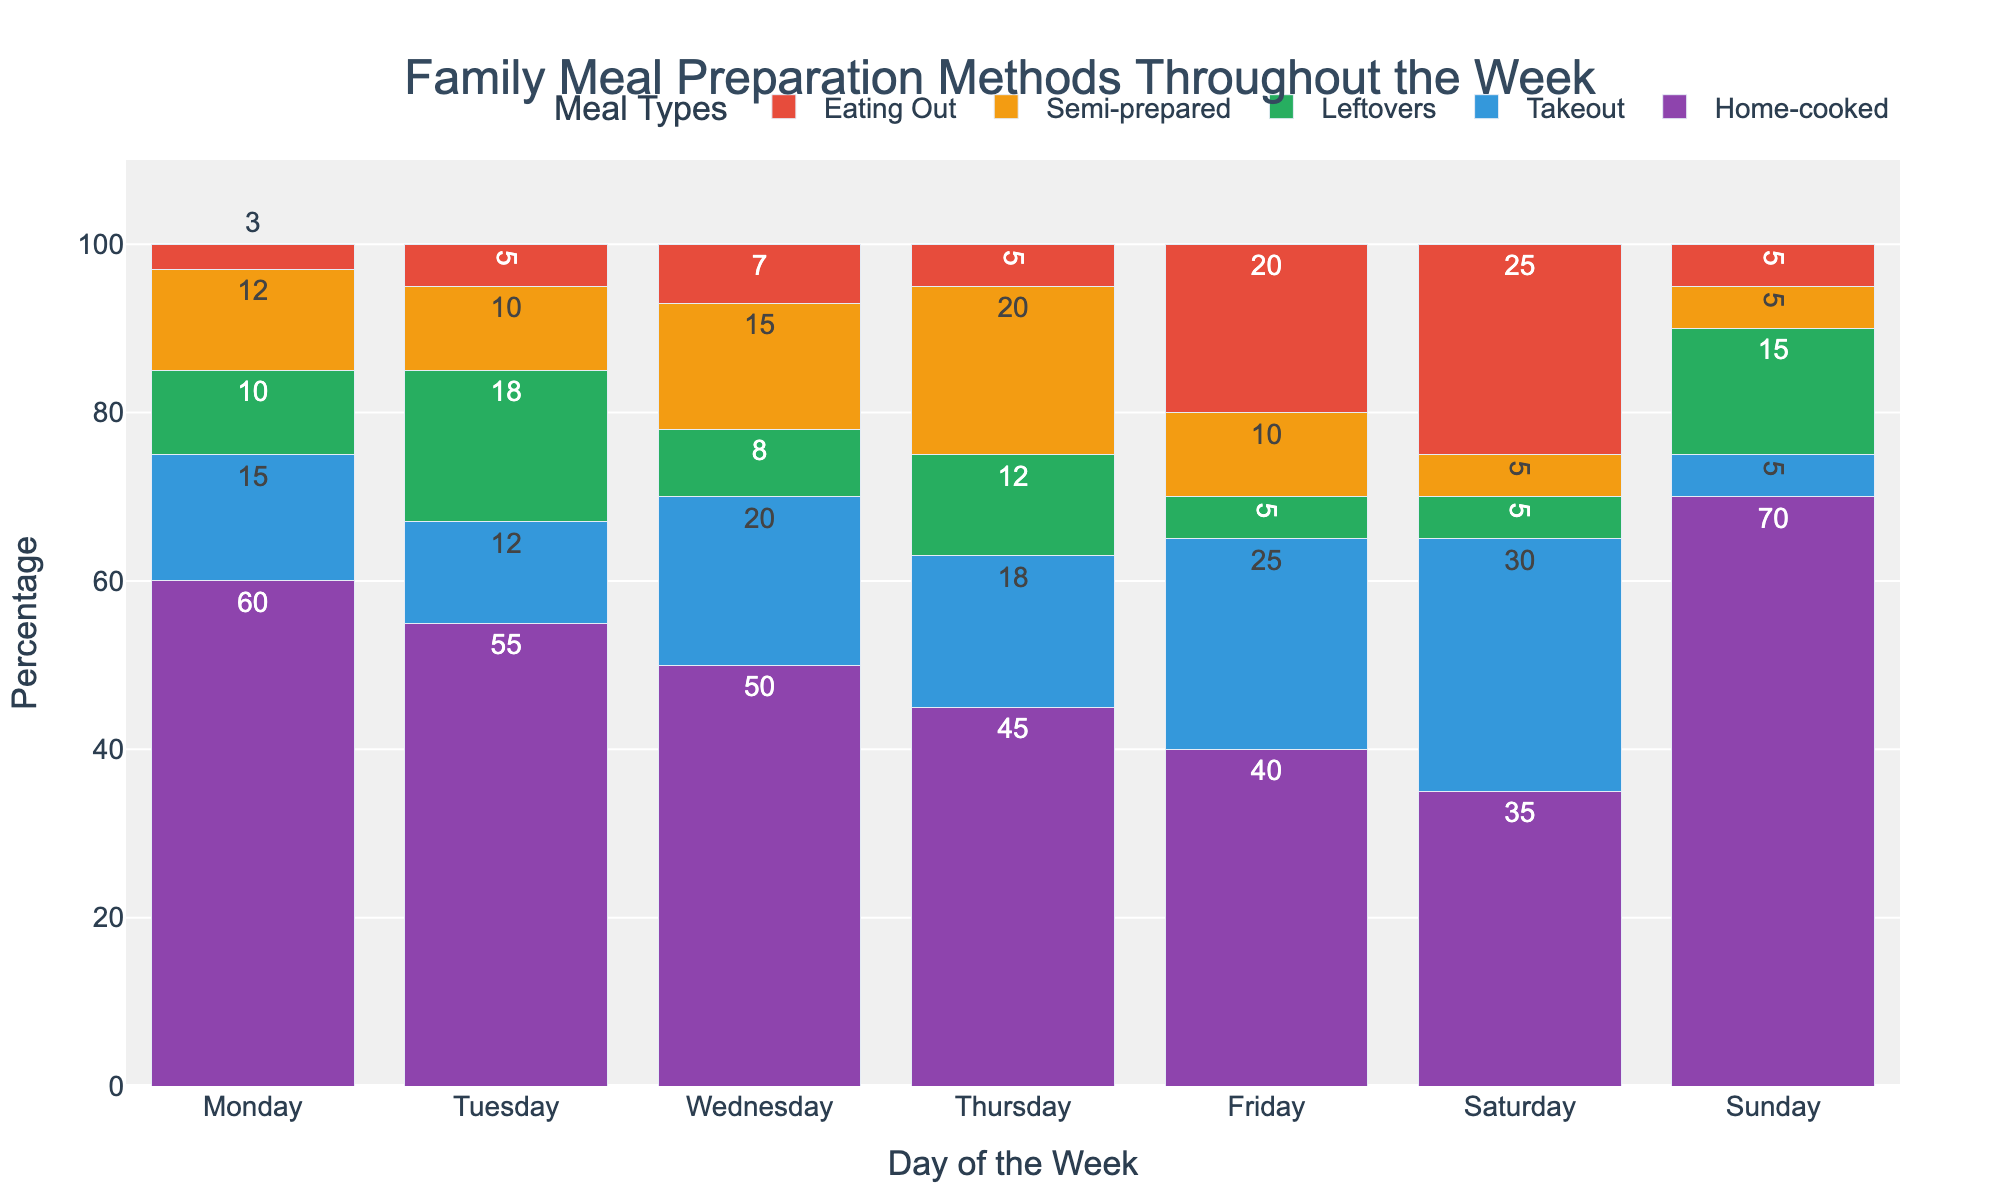What's the most common meal preparation method on Monday? Look at Monday's bars on the chart and identify the tallest one, which represents the highest percentage. The tallest bar on Monday represents Home-cooked meals.
Answer: Home-cooked On which day is the percentage of eating out highest? Compare the Eating Out (red) bars across all days. The tallest Eating Out bar is on Saturday.
Answer: Saturday How does the percentage of home-cooked meals on Sunday compare to Wednesday? Check the Home-cooked (purple) bars for both Sunday and Wednesday. Sunday's bar is taller than Wednesday's.
Answer: Sunday is higher What is the sum of takeout meals on Monday and Tuesday? Add the takeout percentages for Monday and Tuesday. Monday has 15% and Tuesday has 12%, so 15 + 12 = 27%.
Answer: 27% Which days have more than 15% of meals from leftovers? Observe the Leftovers (green) bars and find those above the 15% mark. Tuesday and Sunday meet this condition.
Answer: Tuesday and Sunday What is the average percentage of home-cooked meals from Monday to Thursday? Sum the percentages of Home-cooked meals from Monday to Thursday and divide by 4. The sum is 60 + 55 + 50 + 45 = 210, so the average is 210 / 4 = 52.5%.
Answer: 52.5% Which day has the least percentage for semi-prepared meals? Look at the Semi-prepared (orange) bars and identify the shortest one. Saturday's bar is the shortest for Semi-prepared meals.
Answer: Saturday How many days have fewer than 10% takeout meals? Check the Takeout (blue) bars and count those shorter than the 10% mark. Only Sunday is below 10%.
Answer: 1 day (Sunday) Which meals show an increasing trend from Monday to Friday? Examine the pattern of each meal type from Monday to Friday. The Takeout (blue) and Eating Out (red) bars show an increasing trend.
Answer: Takeout and Eating Out What's the difference in the percentage of Eating Out between Friday and Monday? Subtract the Eating Out percentage on Monday from that on Friday. Friday's Eating Out is 20%, and Monday's is 3%, so 20 - 3 = 17%.
Answer: 17% 